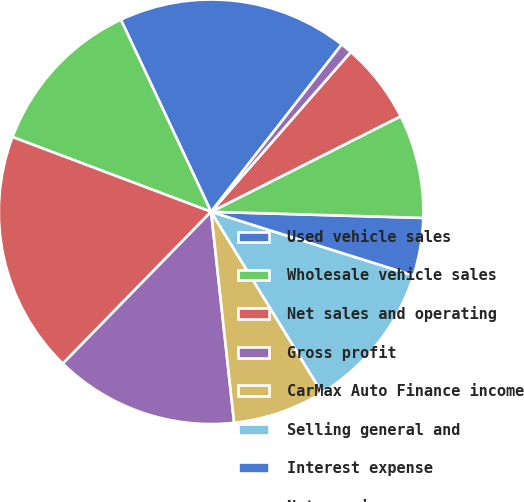<chart> <loc_0><loc_0><loc_500><loc_500><pie_chart><fcel>Used vehicle sales<fcel>Wholesale vehicle sales<fcel>Net sales and operating<fcel>Gross profit<fcel>CarMax Auto Finance income<fcel>Selling general and<fcel>Interest expense<fcel>Net earnings<fcel>Weighted average diluted<fcel>Diluted net earnings per share<nl><fcel>17.54%<fcel>12.28%<fcel>18.42%<fcel>14.04%<fcel>7.02%<fcel>11.4%<fcel>4.39%<fcel>7.89%<fcel>6.14%<fcel>0.88%<nl></chart> 